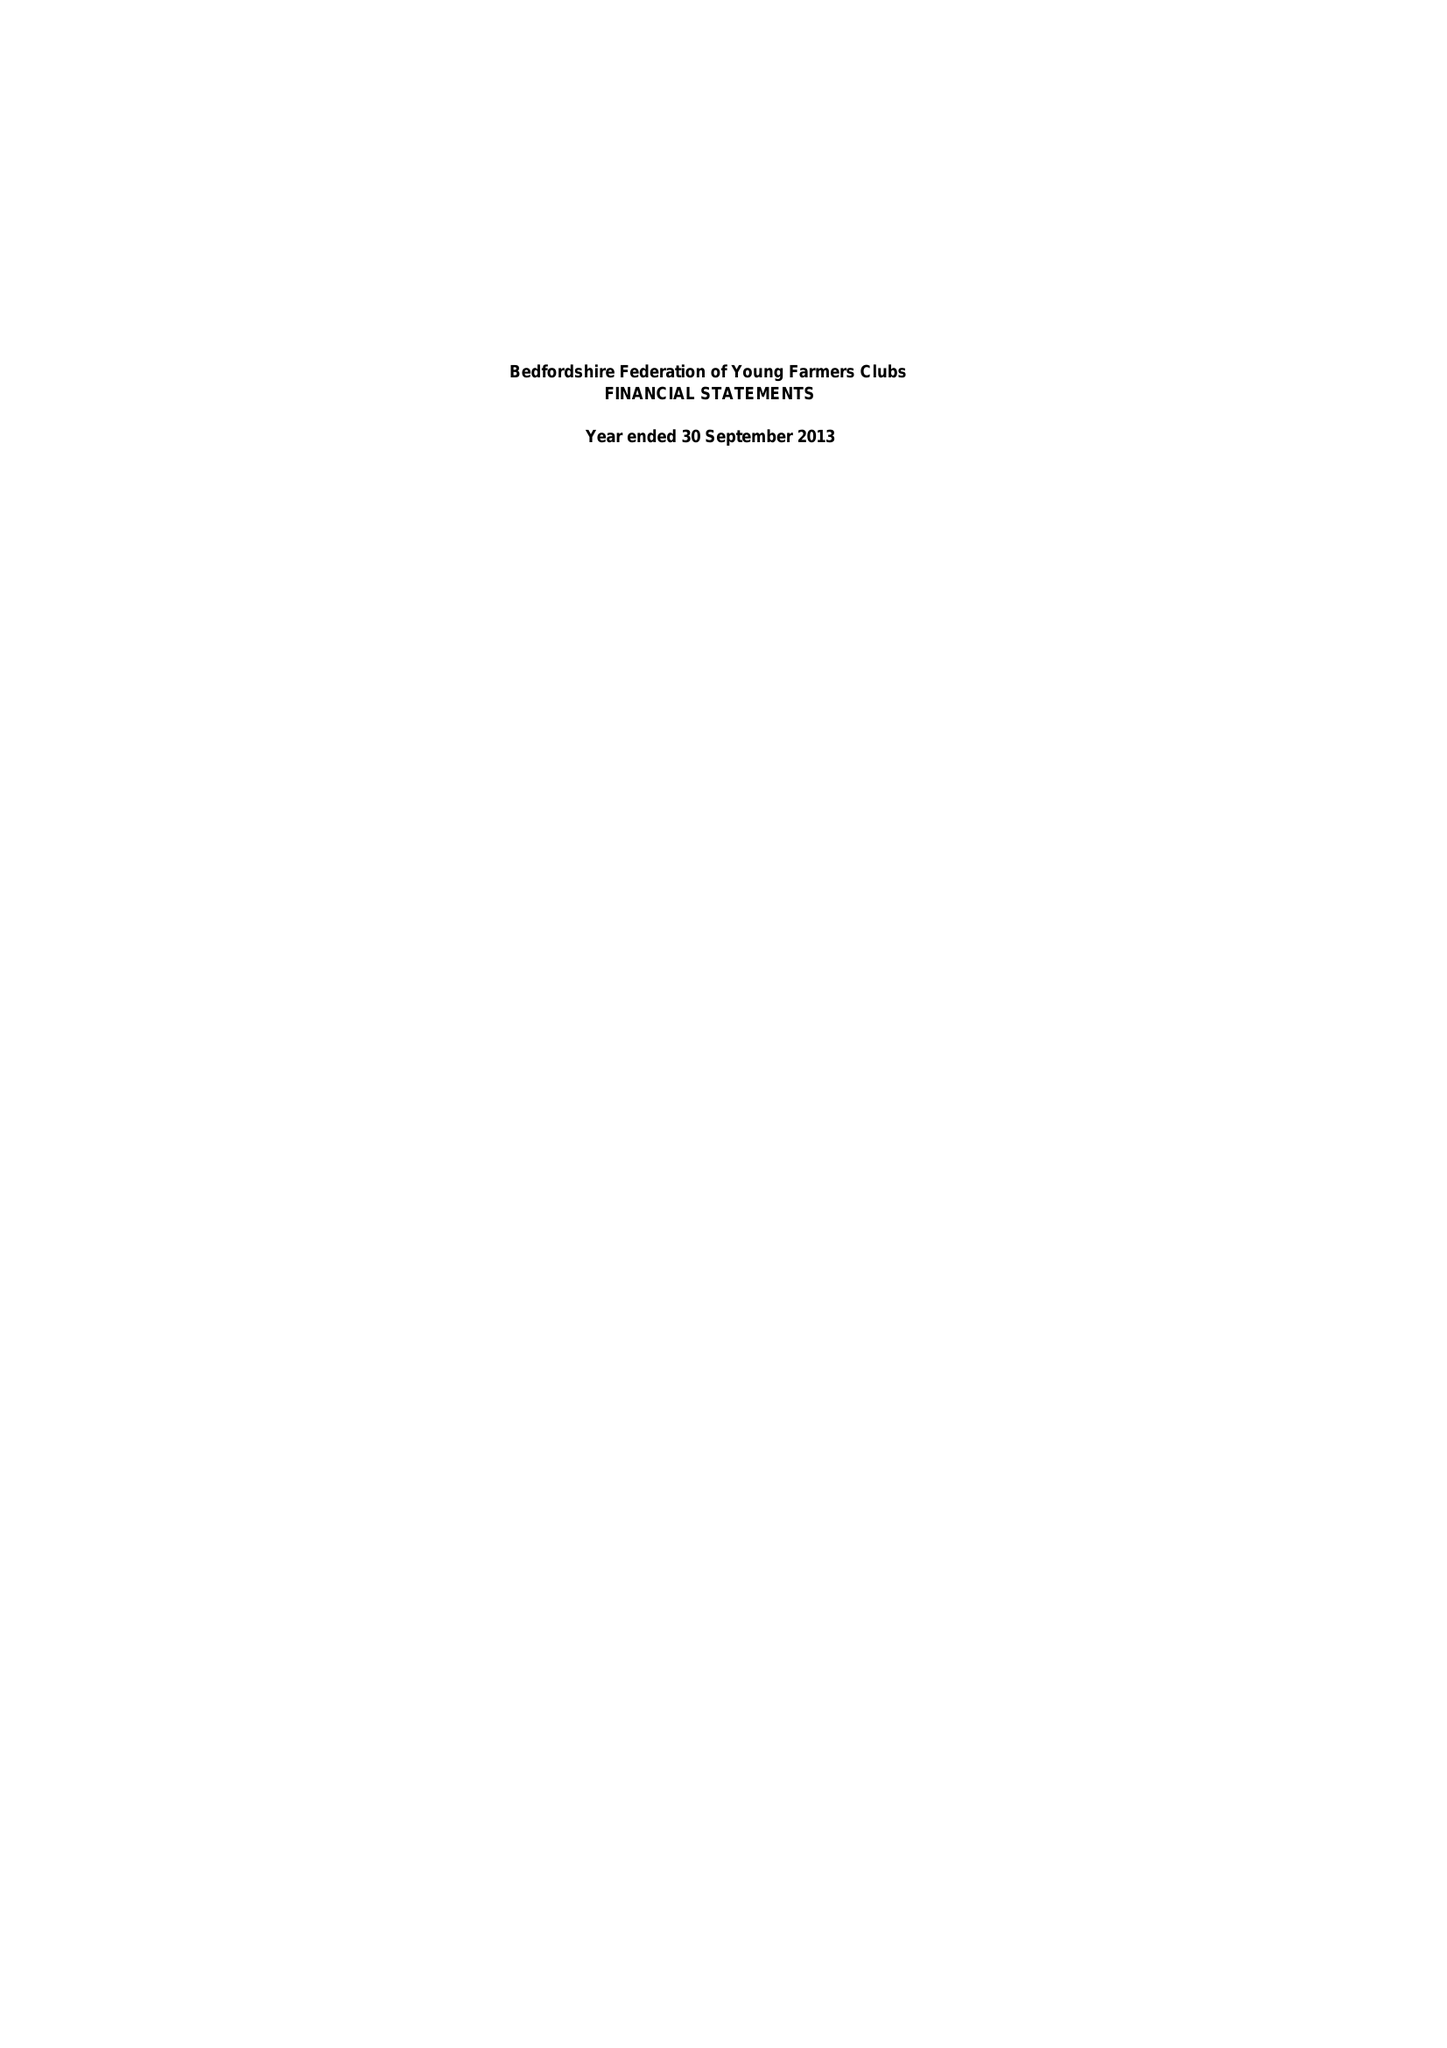What is the value for the address__street_line?
Answer the question using a single word or phrase. None 